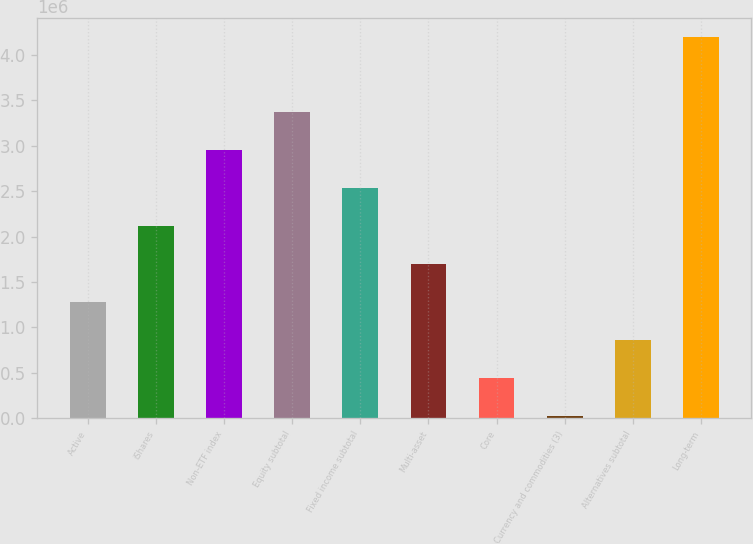Convert chart to OTSL. <chart><loc_0><loc_0><loc_500><loc_500><bar_chart><fcel>Active<fcel>iShares<fcel>Non-ETF index<fcel>Equity subtotal<fcel>Fixed income subtotal<fcel>Multi-asset<fcel>Core<fcel>Currency and commodities (3)<fcel>Alternatives subtotal<fcel>Long-term<nl><fcel>1.27911e+06<fcel>2.11426e+06<fcel>2.94941e+06<fcel>3.36699e+06<fcel>2.53184e+06<fcel>1.69669e+06<fcel>443962<fcel>26387<fcel>861537<fcel>4.20214e+06<nl></chart> 